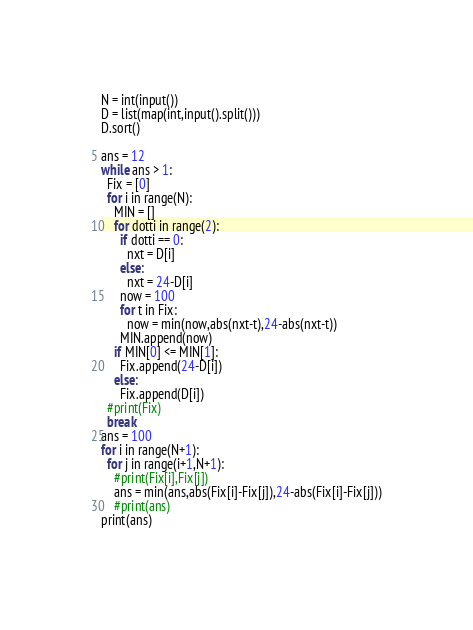Convert code to text. <code><loc_0><loc_0><loc_500><loc_500><_Python_>N = int(input())
D = list(map(int,input().split()))
D.sort()

ans = 12
while ans > 1:
  Fix = [0]
  for i in range(N):
    MIN = []
    for dotti in range(2):
      if dotti == 0:
        nxt = D[i]
      else:
        nxt = 24-D[i]
      now = 100
      for t in Fix:
        now = min(now,abs(nxt-t),24-abs(nxt-t))
      MIN.append(now)
    if MIN[0] <= MIN[1]:
      Fix.append(24-D[i])
    else:
      Fix.append(D[i])
  #print(Fix)
  break
ans = 100
for i in range(N+1):
  for j in range(i+1,N+1):
    #print(Fix[i],Fix[j])
    ans = min(ans,abs(Fix[i]-Fix[j]),24-abs(Fix[i]-Fix[j]))
    #print(ans)
print(ans)
        </code> 